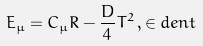<formula> <loc_0><loc_0><loc_500><loc_500>E _ { \mu } = C _ { \mu } R - \frac { D } { 4 } T ^ { 2 } \, , \in d e n t</formula> 